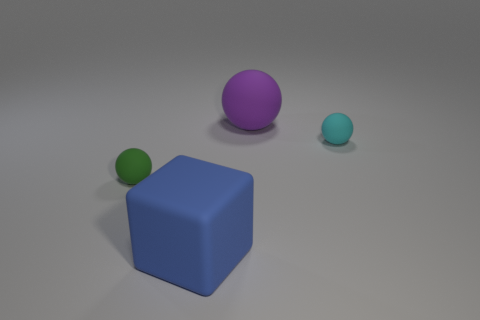Add 2 cyan objects. How many objects exist? 6 Subtract all balls. How many objects are left? 1 Add 1 blue cubes. How many blue cubes exist? 2 Subtract 0 red cylinders. How many objects are left? 4 Subtract all tiny green balls. Subtract all blue matte blocks. How many objects are left? 2 Add 1 purple objects. How many purple objects are left? 2 